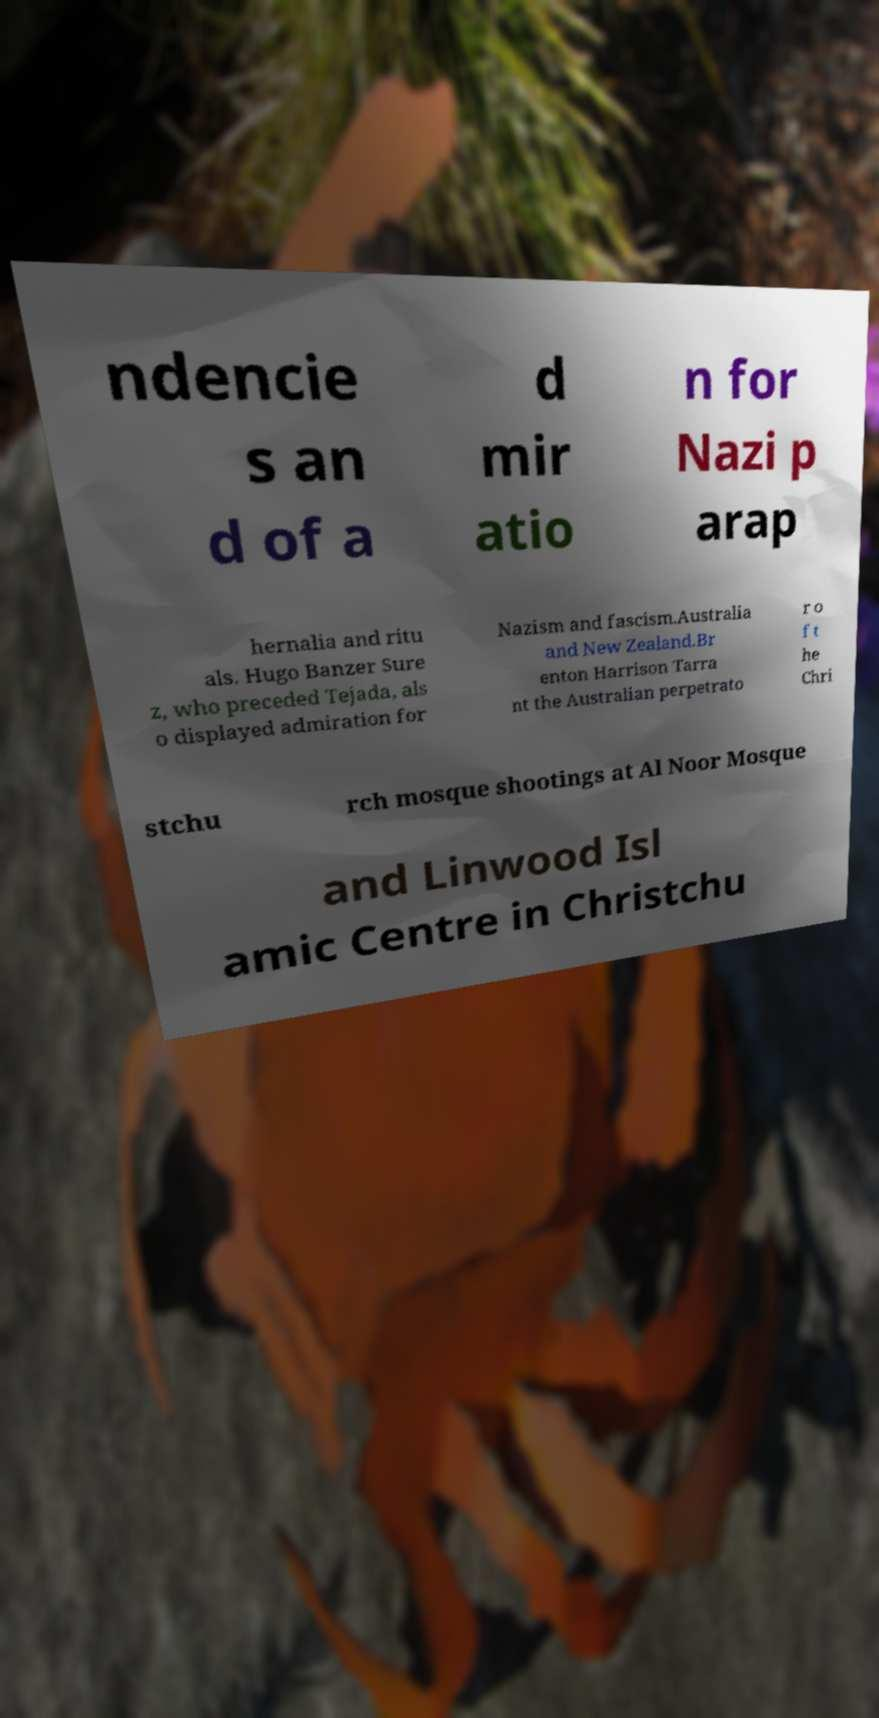What messages or text are displayed in this image? I need them in a readable, typed format. ndencie s an d of a d mir atio n for Nazi p arap hernalia and ritu als. Hugo Banzer Sure z, who preceded Tejada, als o displayed admiration for Nazism and fascism.Australia and New Zealand.Br enton Harrison Tarra nt the Australian perpetrato r o f t he Chri stchu rch mosque shootings at Al Noor Mosque and Linwood Isl amic Centre in Christchu 